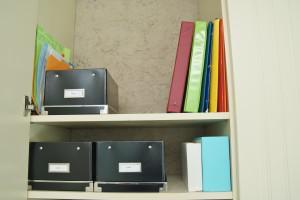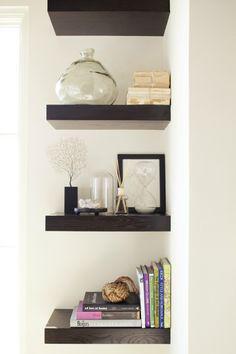The first image is the image on the left, the second image is the image on the right. Evaluate the accuracy of this statement regarding the images: "Three white bookcases sit on a brown wood floor, and one of them has two vases on top.". Is it true? Answer yes or no. No. The first image is the image on the left, the second image is the image on the right. Considering the images on both sides, is "At least one image shows a white cabinet containing some type of sky blue ceramic vessel." valid? Answer yes or no. No. 